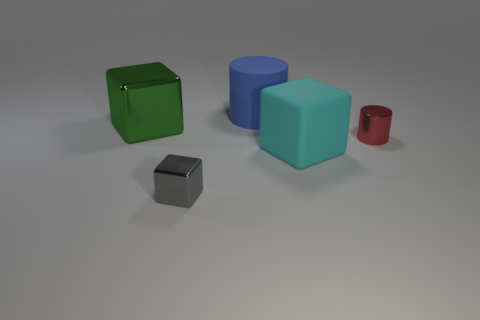There is another thing that is made of the same material as the large blue object; what size is it?
Give a very brief answer. Large. Are there fewer red shiny blocks than green metallic objects?
Give a very brief answer. Yes. What material is the gray block that is the same size as the red thing?
Provide a succinct answer. Metal. Is the number of big blue matte objects greater than the number of tiny purple matte spheres?
Offer a terse response. Yes. What number of matte objects are both behind the green metallic object and in front of the big green metallic block?
Give a very brief answer. 0. Are there any other things that are the same size as the red shiny cylinder?
Ensure brevity in your answer.  Yes. Are there more tiny metal things that are behind the metallic cylinder than small metal cubes that are right of the tiny gray object?
Offer a terse response. No. There is a big cube on the right side of the big green metal thing; what material is it?
Offer a terse response. Rubber. There is a blue rubber object; is its shape the same as the large matte object that is in front of the matte cylinder?
Offer a very short reply. No. How many small objects are to the left of the large object in front of the tiny metallic thing that is behind the tiny shiny block?
Offer a terse response. 1. 